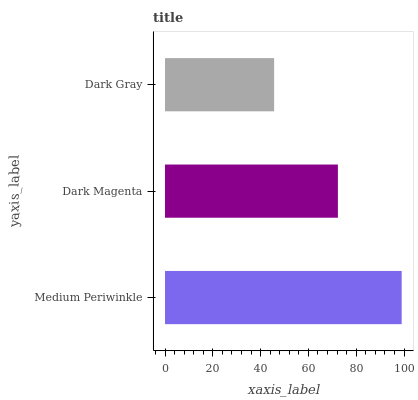Is Dark Gray the minimum?
Answer yes or no. Yes. Is Medium Periwinkle the maximum?
Answer yes or no. Yes. Is Dark Magenta the minimum?
Answer yes or no. No. Is Dark Magenta the maximum?
Answer yes or no. No. Is Medium Periwinkle greater than Dark Magenta?
Answer yes or no. Yes. Is Dark Magenta less than Medium Periwinkle?
Answer yes or no. Yes. Is Dark Magenta greater than Medium Periwinkle?
Answer yes or no. No. Is Medium Periwinkle less than Dark Magenta?
Answer yes or no. No. Is Dark Magenta the high median?
Answer yes or no. Yes. Is Dark Magenta the low median?
Answer yes or no. Yes. Is Medium Periwinkle the high median?
Answer yes or no. No. Is Medium Periwinkle the low median?
Answer yes or no. No. 